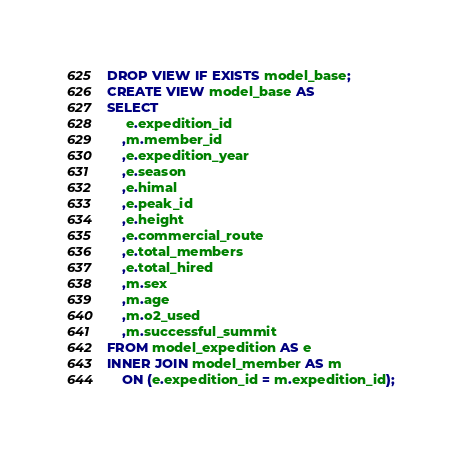Convert code to text. <code><loc_0><loc_0><loc_500><loc_500><_SQL_>DROP VIEW IF EXISTS model_base;
CREATE VIEW model_base AS
SELECT
     e.expedition_id
    ,m.member_id
    ,e.expedition_year
    ,e.season
    ,e.himal
    ,e.peak_id
    ,e.height
    ,e.commercial_route
    ,e.total_members
    ,e.total_hired
    ,m.sex
    ,m.age
    ,m.o2_used
    ,m.successful_summit
FROM model_expedition AS e
INNER JOIN model_member AS m
    ON (e.expedition_id = m.expedition_id);</code> 